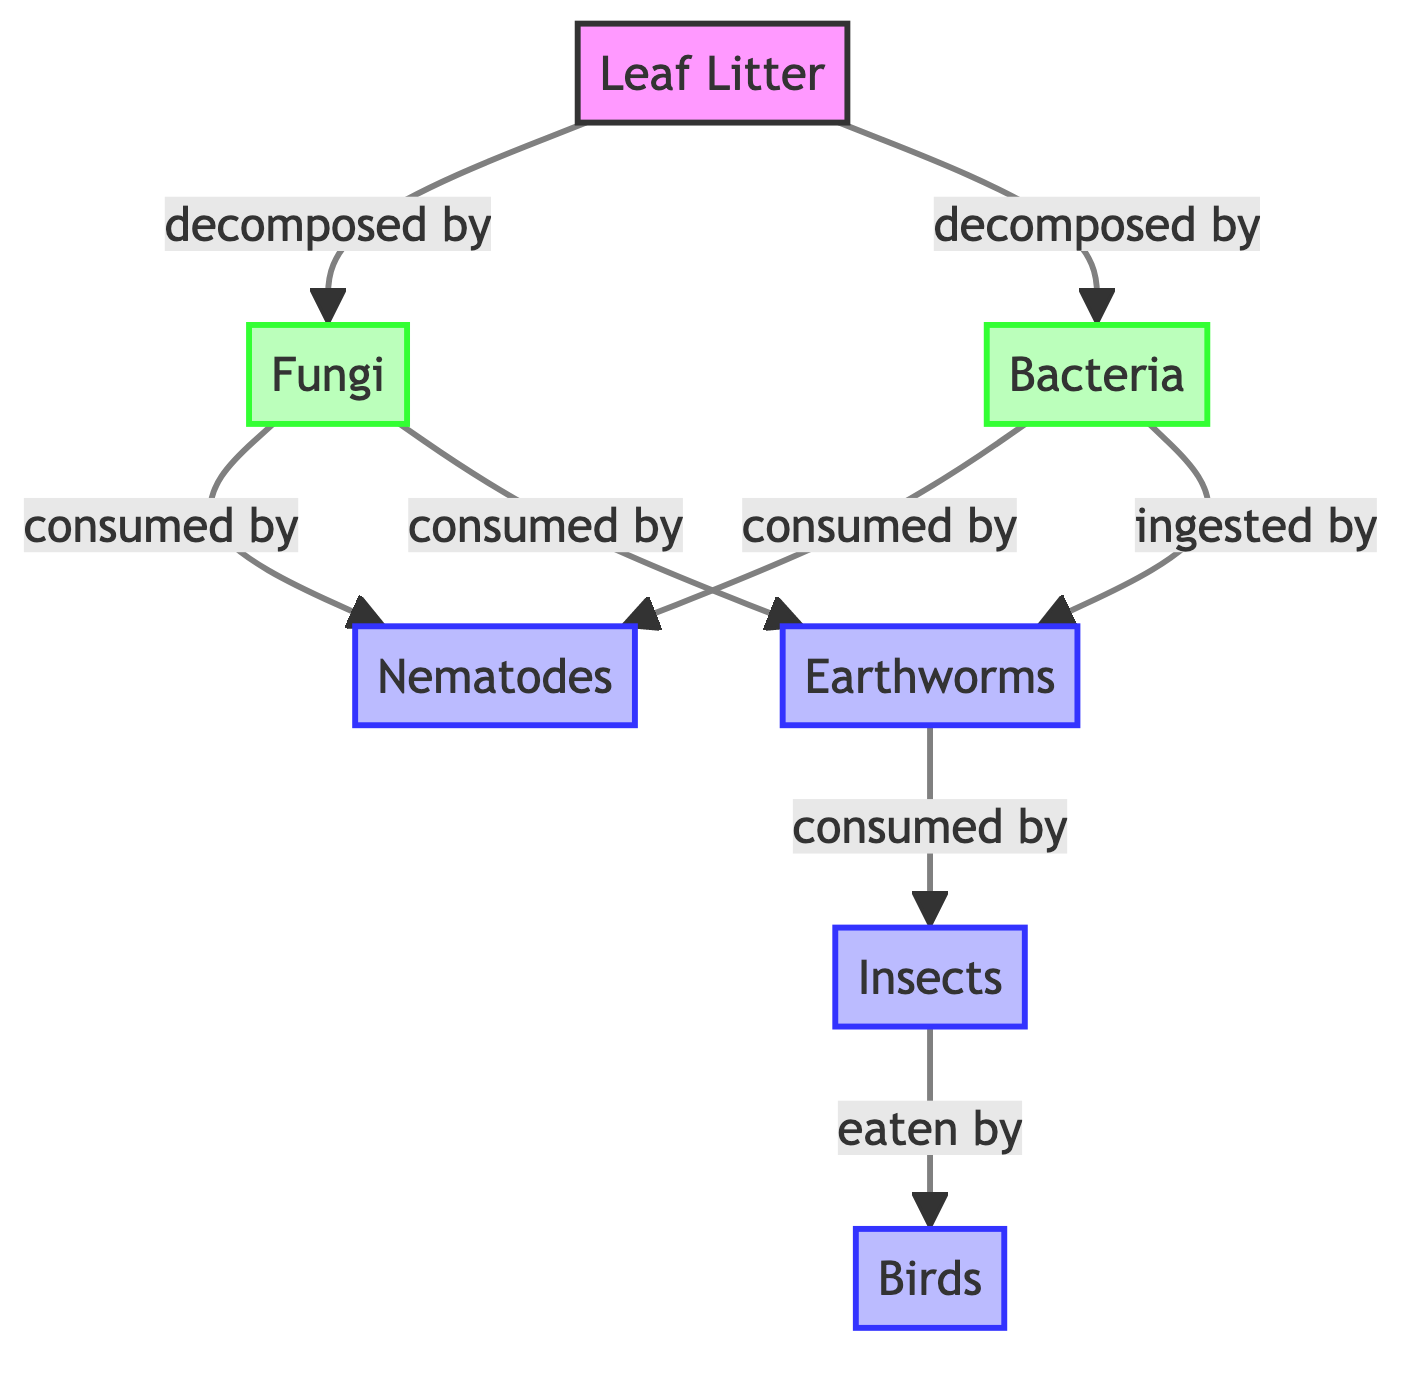What is the first node in the flow of the diagram? The first node, or the starting point of the flow in the diagram, is "Leaf Litter." This is identified as it is where the decomposition process begins in the food chain.
Answer: Leaf Litter How many decomposer nodes are there in the diagram? The diagram contains two decomposer nodes: "Fungi" and "Bacteria." These nodes represent the organisms that break down leaf litter in the ecosystem.
Answer: 2 Which consumer is located after Earthworms in the chain? After "Earthworms," the next consumer in the chain is "Insects." This is determined by following the arrows that indicate which organisms consume others.
Answer: Insects What do Fungi decompose according to the diagram? According to the diagram, "Fungi" decompose "Leaf Litter." This relationship is represented by a directed arrow pointing from "Leaf Litter" to "Fungi."
Answer: Leaf Litter Which organism is at the top of the food chain in this diagram? The organism at the top of the food chain, as illustrated in the diagram, is "Birds." This is the final consumer that is fed by "Insects."
Answer: Birds How many edges are directed towards Bacteria? There are three edges directed towards "Bacteria." These edges represent relationships where other organisms interact with Bacteria, specifically through decomposition and consumption.
Answer: 3 What type of relationship exists between Earthworms and Insects? The type of relationship between "Earthworms" and "Insects" is that "Earthworms" are consumed by "Insects." This is indicated by the direction of the arrow pointing from Earthworms to Insects.
Answer: consumed by Which consumers feed on both Fungi and Bacteria? The consumers that feed on both "Fungi" and "Bacteria" are "Nematodes" and "Earthworms." The arrows point from both decomposers to these two consumers.
Answer: Nematodes, Earthworms What is the primary role of the decomposer nodes in this food chain? The primary role of the decomposer nodes, which are "Fungi" and "Bacteria," is to break down "Leaf Litter." This increases nutrient availability in the ecosystem, which is depicted in the diagram through their direct connection to leaf litter.
Answer: break down Leaf Litter 